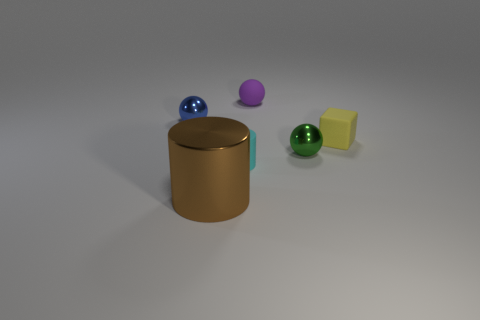Add 1 cylinders. How many objects exist? 7 Subtract all cubes. How many objects are left? 5 Add 4 blue shiny things. How many blue shiny things exist? 5 Subtract 0 cyan balls. How many objects are left? 6 Subtract all small cyan cylinders. Subtract all tiny yellow shiny objects. How many objects are left? 5 Add 1 small cyan matte things. How many small cyan matte things are left? 2 